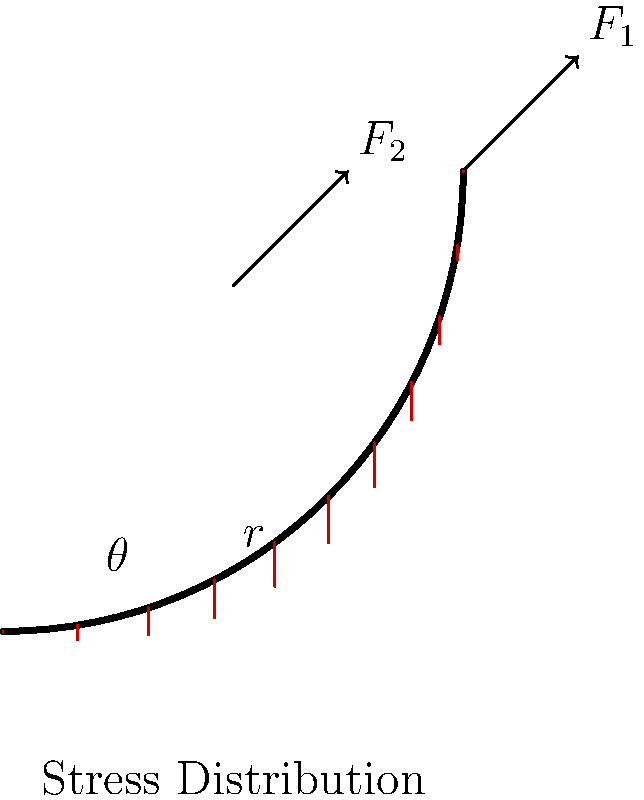As an animated film producer, you're designing a character who's an engineer working on a curved structure. To accurately portray the character's expertise, you need to understand the stress distribution in a curved beam. Given a curved beam with radius $r$ and angle $\theta$, subjected to forces $F_1$ and $F_2$ as shown, what is the general expression for the bending stress $\sigma$ at any point along the beam's cross-section? To determine the bending stress in a curved beam, we follow these steps:

1. Recall the formula for bending stress in a curved beam:
   $$\sigma = -\frac{My}{Ae(R-y)}$$
   Where:
   - $M$ is the bending moment
   - $y$ is the distance from the neutral axis
   - $A$ is the cross-sectional area
   - $e$ is the distance from the centroidal axis to the neutral axis
   - $R$ is the radius of curvature

2. For a curved beam, $e$ is given by:
   $$e = \frac{A}{\int_A \frac{dA}{R-y}}$$

3. The bending moment $M$ is a function of the applied forces $F_1$ and $F_2$, and their positions. It varies along the beam.

4. Substituting these into the stress equation:
   $$\sigma = -\frac{M(F_1, F_2, \theta)y}{A\left(\frac{A}{\int_A \frac{dA}{r-y}}\right)(r-y)}$$

5. Simplifying:
   $$\sigma = -\frac{M(F_1, F_2, \theta)y\int_A \frac{dA}{r-y}}{A^2(r-y)}$$

This expression gives the general form of the bending stress at any point in the curved beam's cross-section, accounting for the applied forces and the beam's geometry.
Answer: $$\sigma = -\frac{M(F_1, F_2, \theta)y\int_A \frac{dA}{r-y}}{A^2(r-y)}$$ 